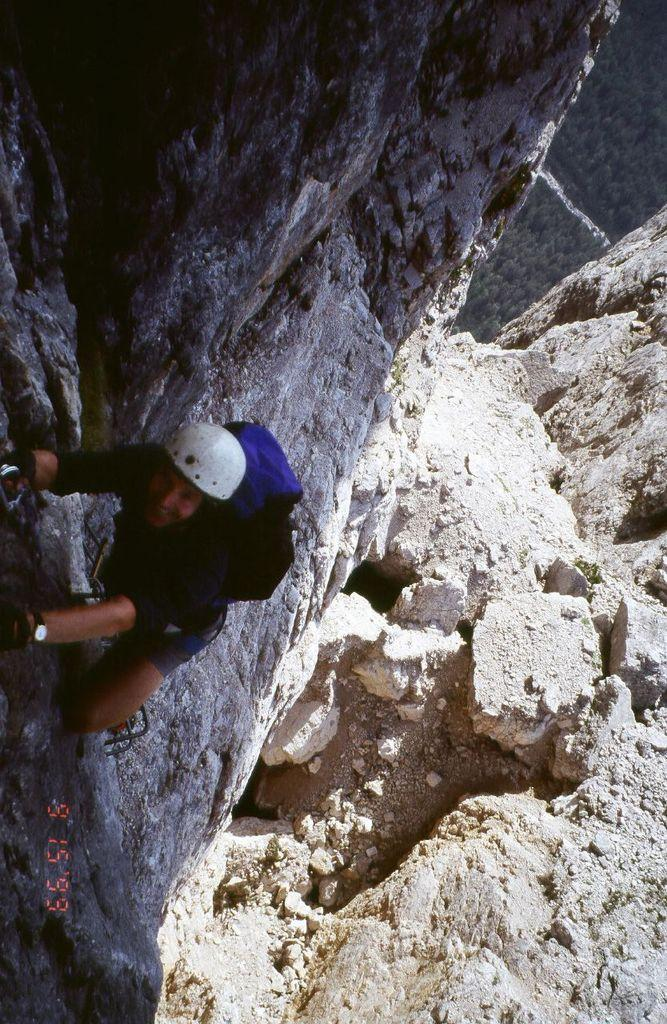Who is the main subject in the image? There is a person in the image. What is the person doing in the image? The person is climbing a mountain. What can be seen in the background of the image? The mountain is visible in the background of the image. What type of cloth is the pig wearing in the image? There is no pig or cloth present in the image; it features a person climbing a mountain. 